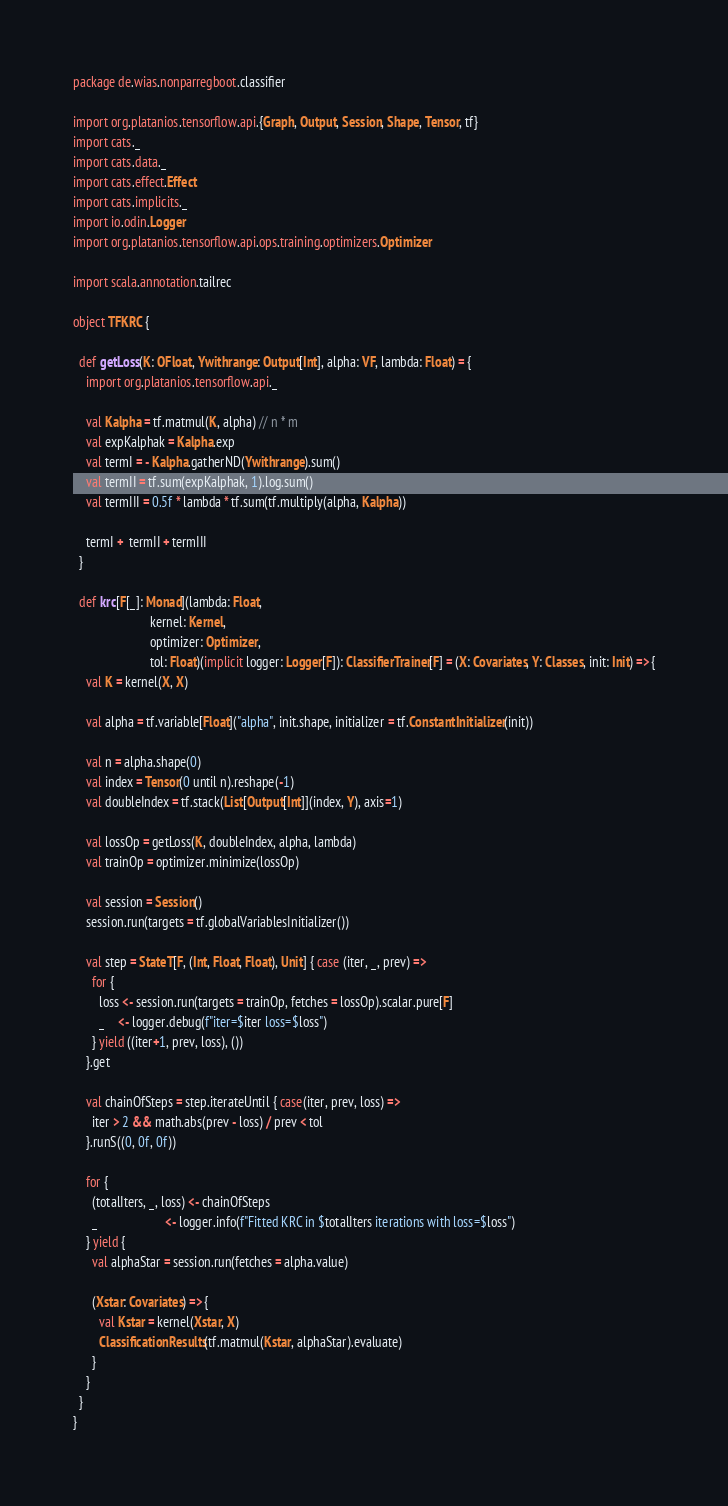Convert code to text. <code><loc_0><loc_0><loc_500><loc_500><_Scala_>package de.wias.nonparregboot.classifier

import org.platanios.tensorflow.api.{Graph, Output, Session, Shape, Tensor, tf}
import cats._
import cats.data._
import cats.effect.Effect
import cats.implicits._
import io.odin.Logger
import org.platanios.tensorflow.api.ops.training.optimizers.Optimizer

import scala.annotation.tailrec

object TFKRC {

  def getLoss(K: OFloat, Ywithrange: Output[Int], alpha: VF, lambda: Float) = {
    import org.platanios.tensorflow.api._

    val Kalpha = tf.matmul(K, alpha) // n * m
    val expKalphak = Kalpha.exp
    val termI = - Kalpha.gatherND(Ywithrange).sum()
    val termII = tf.sum(expKalphak, 1).log.sum()
    val termIII = 0.5f * lambda * tf.sum(tf.multiply(alpha, Kalpha))

    termI +  termII + termIII
  }

  def krc[F[_]: Monad](lambda: Float,
                        kernel: Kernel,
                        optimizer: Optimizer,
                        tol: Float)(implicit logger: Logger[F]): ClassifierTrainer[F] = (X: Covariates, Y: Classes, init: Init) => {
    val K = kernel(X, X)

    val alpha = tf.variable[Float]("alpha", init.shape, initializer = tf.ConstantInitializer(init))

    val n = alpha.shape(0)
    val index = Tensor(0 until n).reshape(-1)
    val doubleIndex = tf.stack(List[Output[Int]](index, Y), axis=1)

    val lossOp = getLoss(K, doubleIndex, alpha, lambda)
    val trainOp = optimizer.minimize(lossOp)

    val session = Session()
    session.run(targets = tf.globalVariablesInitializer())

    val step = StateT[F, (Int, Float, Float), Unit] { case (iter, _, prev) =>
      for {
        loss <- session.run(targets = trainOp, fetches = lossOp).scalar.pure[F]
        _    <- logger.debug(f"iter=$iter loss=$loss")
      } yield ((iter+1, prev, loss), ())
    }.get

    val chainOfSteps = step.iterateUntil { case(iter, prev, loss) =>
      iter > 2 && math.abs(prev - loss) / prev < tol
    }.runS((0, 0f, 0f))

    for {
      (totalIters, _, loss) <- chainOfSteps
      _                     <- logger.info(f"Fitted KRC in $totalIters iterations with loss=$loss")
    } yield {
      val alphaStar = session.run(fetches = alpha.value)

      (Xstar: Covariates) => {
        val Kstar = kernel(Xstar, X)
        ClassificationResults(tf.matmul(Kstar, alphaStar).evaluate)
      }
    }
  }
}
</code> 